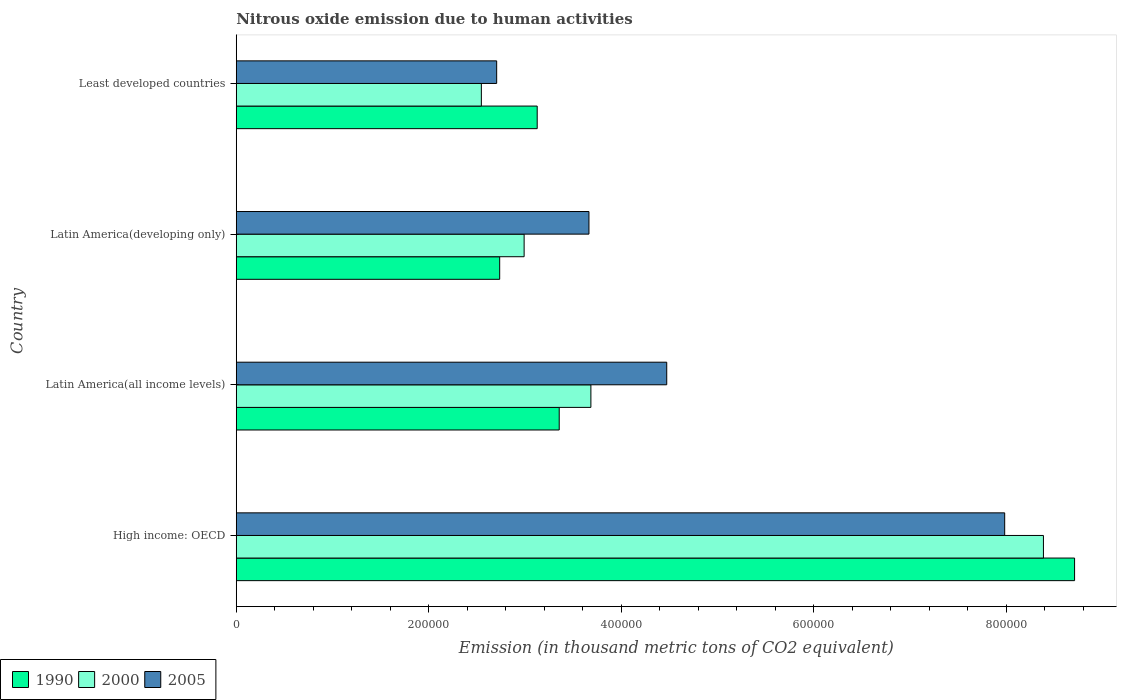How many groups of bars are there?
Give a very brief answer. 4. Are the number of bars per tick equal to the number of legend labels?
Ensure brevity in your answer.  Yes. How many bars are there on the 4th tick from the top?
Your answer should be compact. 3. How many bars are there on the 4th tick from the bottom?
Your answer should be compact. 3. What is the label of the 2nd group of bars from the top?
Provide a succinct answer. Latin America(developing only). In how many cases, is the number of bars for a given country not equal to the number of legend labels?
Your answer should be compact. 0. What is the amount of nitrous oxide emitted in 2000 in Latin America(developing only)?
Give a very brief answer. 2.99e+05. Across all countries, what is the maximum amount of nitrous oxide emitted in 2005?
Offer a terse response. 7.98e+05. Across all countries, what is the minimum amount of nitrous oxide emitted in 2005?
Provide a short and direct response. 2.71e+05. In which country was the amount of nitrous oxide emitted in 2000 maximum?
Offer a very short reply. High income: OECD. In which country was the amount of nitrous oxide emitted in 1990 minimum?
Offer a very short reply. Latin America(developing only). What is the total amount of nitrous oxide emitted in 1990 in the graph?
Offer a very short reply. 1.79e+06. What is the difference between the amount of nitrous oxide emitted in 2005 in Latin America(all income levels) and that in Least developed countries?
Ensure brevity in your answer.  1.77e+05. What is the difference between the amount of nitrous oxide emitted in 2005 in High income: OECD and the amount of nitrous oxide emitted in 2000 in Latin America(developing only)?
Your answer should be very brief. 4.99e+05. What is the average amount of nitrous oxide emitted in 2005 per country?
Keep it short and to the point. 4.71e+05. What is the difference between the amount of nitrous oxide emitted in 2005 and amount of nitrous oxide emitted in 1990 in Latin America(all income levels)?
Your answer should be very brief. 1.12e+05. What is the ratio of the amount of nitrous oxide emitted in 2005 in High income: OECD to that in Latin America(all income levels)?
Ensure brevity in your answer.  1.79. What is the difference between the highest and the second highest amount of nitrous oxide emitted in 2000?
Ensure brevity in your answer.  4.70e+05. What is the difference between the highest and the lowest amount of nitrous oxide emitted in 1990?
Your answer should be compact. 5.97e+05. Is the sum of the amount of nitrous oxide emitted in 2005 in High income: OECD and Latin America(all income levels) greater than the maximum amount of nitrous oxide emitted in 1990 across all countries?
Your answer should be very brief. Yes. What does the 1st bar from the top in Latin America(all income levels) represents?
Give a very brief answer. 2005. What does the 3rd bar from the bottom in Latin America(all income levels) represents?
Provide a short and direct response. 2005. Is it the case that in every country, the sum of the amount of nitrous oxide emitted in 2000 and amount of nitrous oxide emitted in 2005 is greater than the amount of nitrous oxide emitted in 1990?
Your response must be concise. Yes. How many bars are there?
Make the answer very short. 12. What is the difference between two consecutive major ticks on the X-axis?
Your answer should be compact. 2.00e+05. Are the values on the major ticks of X-axis written in scientific E-notation?
Keep it short and to the point. No. Does the graph contain any zero values?
Your answer should be very brief. No. Where does the legend appear in the graph?
Provide a succinct answer. Bottom left. What is the title of the graph?
Keep it short and to the point. Nitrous oxide emission due to human activities. What is the label or title of the X-axis?
Your answer should be very brief. Emission (in thousand metric tons of CO2 equivalent). What is the label or title of the Y-axis?
Ensure brevity in your answer.  Country. What is the Emission (in thousand metric tons of CO2 equivalent) of 1990 in High income: OECD?
Your answer should be very brief. 8.71e+05. What is the Emission (in thousand metric tons of CO2 equivalent) in 2000 in High income: OECD?
Offer a terse response. 8.39e+05. What is the Emission (in thousand metric tons of CO2 equivalent) in 2005 in High income: OECD?
Ensure brevity in your answer.  7.98e+05. What is the Emission (in thousand metric tons of CO2 equivalent) of 1990 in Latin America(all income levels)?
Offer a very short reply. 3.36e+05. What is the Emission (in thousand metric tons of CO2 equivalent) in 2000 in Latin America(all income levels)?
Your answer should be very brief. 3.68e+05. What is the Emission (in thousand metric tons of CO2 equivalent) of 2005 in Latin America(all income levels)?
Make the answer very short. 4.47e+05. What is the Emission (in thousand metric tons of CO2 equivalent) of 1990 in Latin America(developing only)?
Ensure brevity in your answer.  2.74e+05. What is the Emission (in thousand metric tons of CO2 equivalent) of 2000 in Latin America(developing only)?
Give a very brief answer. 2.99e+05. What is the Emission (in thousand metric tons of CO2 equivalent) in 2005 in Latin America(developing only)?
Offer a very short reply. 3.66e+05. What is the Emission (in thousand metric tons of CO2 equivalent) of 1990 in Least developed countries?
Provide a succinct answer. 3.13e+05. What is the Emission (in thousand metric tons of CO2 equivalent) in 2000 in Least developed countries?
Your answer should be compact. 2.55e+05. What is the Emission (in thousand metric tons of CO2 equivalent) of 2005 in Least developed countries?
Provide a succinct answer. 2.71e+05. Across all countries, what is the maximum Emission (in thousand metric tons of CO2 equivalent) of 1990?
Make the answer very short. 8.71e+05. Across all countries, what is the maximum Emission (in thousand metric tons of CO2 equivalent) in 2000?
Offer a terse response. 8.39e+05. Across all countries, what is the maximum Emission (in thousand metric tons of CO2 equivalent) of 2005?
Offer a very short reply. 7.98e+05. Across all countries, what is the minimum Emission (in thousand metric tons of CO2 equivalent) in 1990?
Your answer should be very brief. 2.74e+05. Across all countries, what is the minimum Emission (in thousand metric tons of CO2 equivalent) in 2000?
Ensure brevity in your answer.  2.55e+05. Across all countries, what is the minimum Emission (in thousand metric tons of CO2 equivalent) of 2005?
Give a very brief answer. 2.71e+05. What is the total Emission (in thousand metric tons of CO2 equivalent) in 1990 in the graph?
Provide a succinct answer. 1.79e+06. What is the total Emission (in thousand metric tons of CO2 equivalent) in 2000 in the graph?
Ensure brevity in your answer.  1.76e+06. What is the total Emission (in thousand metric tons of CO2 equivalent) of 2005 in the graph?
Keep it short and to the point. 1.88e+06. What is the difference between the Emission (in thousand metric tons of CO2 equivalent) in 1990 in High income: OECD and that in Latin America(all income levels)?
Make the answer very short. 5.35e+05. What is the difference between the Emission (in thousand metric tons of CO2 equivalent) in 2000 in High income: OECD and that in Latin America(all income levels)?
Give a very brief answer. 4.70e+05. What is the difference between the Emission (in thousand metric tons of CO2 equivalent) in 2005 in High income: OECD and that in Latin America(all income levels)?
Provide a succinct answer. 3.51e+05. What is the difference between the Emission (in thousand metric tons of CO2 equivalent) of 1990 in High income: OECD and that in Latin America(developing only)?
Your answer should be very brief. 5.97e+05. What is the difference between the Emission (in thousand metric tons of CO2 equivalent) of 2000 in High income: OECD and that in Latin America(developing only)?
Provide a short and direct response. 5.40e+05. What is the difference between the Emission (in thousand metric tons of CO2 equivalent) of 2005 in High income: OECD and that in Latin America(developing only)?
Your response must be concise. 4.32e+05. What is the difference between the Emission (in thousand metric tons of CO2 equivalent) in 1990 in High income: OECD and that in Least developed countries?
Your answer should be compact. 5.58e+05. What is the difference between the Emission (in thousand metric tons of CO2 equivalent) of 2000 in High income: OECD and that in Least developed countries?
Make the answer very short. 5.84e+05. What is the difference between the Emission (in thousand metric tons of CO2 equivalent) in 2005 in High income: OECD and that in Least developed countries?
Give a very brief answer. 5.28e+05. What is the difference between the Emission (in thousand metric tons of CO2 equivalent) of 1990 in Latin America(all income levels) and that in Latin America(developing only)?
Your answer should be compact. 6.18e+04. What is the difference between the Emission (in thousand metric tons of CO2 equivalent) of 2000 in Latin America(all income levels) and that in Latin America(developing only)?
Offer a terse response. 6.94e+04. What is the difference between the Emission (in thousand metric tons of CO2 equivalent) of 2005 in Latin America(all income levels) and that in Latin America(developing only)?
Provide a short and direct response. 8.08e+04. What is the difference between the Emission (in thousand metric tons of CO2 equivalent) in 1990 in Latin America(all income levels) and that in Least developed countries?
Your answer should be compact. 2.29e+04. What is the difference between the Emission (in thousand metric tons of CO2 equivalent) of 2000 in Latin America(all income levels) and that in Least developed countries?
Make the answer very short. 1.14e+05. What is the difference between the Emission (in thousand metric tons of CO2 equivalent) in 2005 in Latin America(all income levels) and that in Least developed countries?
Give a very brief answer. 1.77e+05. What is the difference between the Emission (in thousand metric tons of CO2 equivalent) of 1990 in Latin America(developing only) and that in Least developed countries?
Ensure brevity in your answer.  -3.90e+04. What is the difference between the Emission (in thousand metric tons of CO2 equivalent) in 2000 in Latin America(developing only) and that in Least developed countries?
Provide a short and direct response. 4.44e+04. What is the difference between the Emission (in thousand metric tons of CO2 equivalent) in 2005 in Latin America(developing only) and that in Least developed countries?
Your response must be concise. 9.59e+04. What is the difference between the Emission (in thousand metric tons of CO2 equivalent) in 1990 in High income: OECD and the Emission (in thousand metric tons of CO2 equivalent) in 2000 in Latin America(all income levels)?
Your answer should be compact. 5.03e+05. What is the difference between the Emission (in thousand metric tons of CO2 equivalent) of 1990 in High income: OECD and the Emission (in thousand metric tons of CO2 equivalent) of 2005 in Latin America(all income levels)?
Offer a very short reply. 4.24e+05. What is the difference between the Emission (in thousand metric tons of CO2 equivalent) in 2000 in High income: OECD and the Emission (in thousand metric tons of CO2 equivalent) in 2005 in Latin America(all income levels)?
Provide a succinct answer. 3.91e+05. What is the difference between the Emission (in thousand metric tons of CO2 equivalent) of 1990 in High income: OECD and the Emission (in thousand metric tons of CO2 equivalent) of 2000 in Latin America(developing only)?
Offer a terse response. 5.72e+05. What is the difference between the Emission (in thousand metric tons of CO2 equivalent) in 1990 in High income: OECD and the Emission (in thousand metric tons of CO2 equivalent) in 2005 in Latin America(developing only)?
Offer a very short reply. 5.05e+05. What is the difference between the Emission (in thousand metric tons of CO2 equivalent) in 2000 in High income: OECD and the Emission (in thousand metric tons of CO2 equivalent) in 2005 in Latin America(developing only)?
Provide a short and direct response. 4.72e+05. What is the difference between the Emission (in thousand metric tons of CO2 equivalent) in 1990 in High income: OECD and the Emission (in thousand metric tons of CO2 equivalent) in 2000 in Least developed countries?
Your answer should be compact. 6.16e+05. What is the difference between the Emission (in thousand metric tons of CO2 equivalent) of 1990 in High income: OECD and the Emission (in thousand metric tons of CO2 equivalent) of 2005 in Least developed countries?
Keep it short and to the point. 6.00e+05. What is the difference between the Emission (in thousand metric tons of CO2 equivalent) in 2000 in High income: OECD and the Emission (in thousand metric tons of CO2 equivalent) in 2005 in Least developed countries?
Keep it short and to the point. 5.68e+05. What is the difference between the Emission (in thousand metric tons of CO2 equivalent) in 1990 in Latin America(all income levels) and the Emission (in thousand metric tons of CO2 equivalent) in 2000 in Latin America(developing only)?
Your response must be concise. 3.65e+04. What is the difference between the Emission (in thousand metric tons of CO2 equivalent) in 1990 in Latin America(all income levels) and the Emission (in thousand metric tons of CO2 equivalent) in 2005 in Latin America(developing only)?
Your answer should be compact. -3.09e+04. What is the difference between the Emission (in thousand metric tons of CO2 equivalent) in 2000 in Latin America(all income levels) and the Emission (in thousand metric tons of CO2 equivalent) in 2005 in Latin America(developing only)?
Your answer should be very brief. 2012. What is the difference between the Emission (in thousand metric tons of CO2 equivalent) of 1990 in Latin America(all income levels) and the Emission (in thousand metric tons of CO2 equivalent) of 2000 in Least developed countries?
Your response must be concise. 8.09e+04. What is the difference between the Emission (in thousand metric tons of CO2 equivalent) in 1990 in Latin America(all income levels) and the Emission (in thousand metric tons of CO2 equivalent) in 2005 in Least developed countries?
Offer a very short reply. 6.50e+04. What is the difference between the Emission (in thousand metric tons of CO2 equivalent) of 2000 in Latin America(all income levels) and the Emission (in thousand metric tons of CO2 equivalent) of 2005 in Least developed countries?
Provide a short and direct response. 9.79e+04. What is the difference between the Emission (in thousand metric tons of CO2 equivalent) in 1990 in Latin America(developing only) and the Emission (in thousand metric tons of CO2 equivalent) in 2000 in Least developed countries?
Your answer should be very brief. 1.91e+04. What is the difference between the Emission (in thousand metric tons of CO2 equivalent) in 1990 in Latin America(developing only) and the Emission (in thousand metric tons of CO2 equivalent) in 2005 in Least developed countries?
Keep it short and to the point. 3144.7. What is the difference between the Emission (in thousand metric tons of CO2 equivalent) in 2000 in Latin America(developing only) and the Emission (in thousand metric tons of CO2 equivalent) in 2005 in Least developed countries?
Offer a very short reply. 2.85e+04. What is the average Emission (in thousand metric tons of CO2 equivalent) of 1990 per country?
Your response must be concise. 4.48e+05. What is the average Emission (in thousand metric tons of CO2 equivalent) in 2000 per country?
Ensure brevity in your answer.  4.40e+05. What is the average Emission (in thousand metric tons of CO2 equivalent) of 2005 per country?
Provide a succinct answer. 4.71e+05. What is the difference between the Emission (in thousand metric tons of CO2 equivalent) in 1990 and Emission (in thousand metric tons of CO2 equivalent) in 2000 in High income: OECD?
Your answer should be very brief. 3.24e+04. What is the difference between the Emission (in thousand metric tons of CO2 equivalent) in 1990 and Emission (in thousand metric tons of CO2 equivalent) in 2005 in High income: OECD?
Offer a terse response. 7.26e+04. What is the difference between the Emission (in thousand metric tons of CO2 equivalent) of 2000 and Emission (in thousand metric tons of CO2 equivalent) of 2005 in High income: OECD?
Your answer should be compact. 4.02e+04. What is the difference between the Emission (in thousand metric tons of CO2 equivalent) of 1990 and Emission (in thousand metric tons of CO2 equivalent) of 2000 in Latin America(all income levels)?
Offer a terse response. -3.29e+04. What is the difference between the Emission (in thousand metric tons of CO2 equivalent) in 1990 and Emission (in thousand metric tons of CO2 equivalent) in 2005 in Latin America(all income levels)?
Your answer should be compact. -1.12e+05. What is the difference between the Emission (in thousand metric tons of CO2 equivalent) in 2000 and Emission (in thousand metric tons of CO2 equivalent) in 2005 in Latin America(all income levels)?
Offer a terse response. -7.88e+04. What is the difference between the Emission (in thousand metric tons of CO2 equivalent) of 1990 and Emission (in thousand metric tons of CO2 equivalent) of 2000 in Latin America(developing only)?
Your response must be concise. -2.54e+04. What is the difference between the Emission (in thousand metric tons of CO2 equivalent) in 1990 and Emission (in thousand metric tons of CO2 equivalent) in 2005 in Latin America(developing only)?
Provide a short and direct response. -9.27e+04. What is the difference between the Emission (in thousand metric tons of CO2 equivalent) in 2000 and Emission (in thousand metric tons of CO2 equivalent) in 2005 in Latin America(developing only)?
Your answer should be very brief. -6.74e+04. What is the difference between the Emission (in thousand metric tons of CO2 equivalent) in 1990 and Emission (in thousand metric tons of CO2 equivalent) in 2000 in Least developed countries?
Give a very brief answer. 5.80e+04. What is the difference between the Emission (in thousand metric tons of CO2 equivalent) of 1990 and Emission (in thousand metric tons of CO2 equivalent) of 2005 in Least developed countries?
Your answer should be very brief. 4.21e+04. What is the difference between the Emission (in thousand metric tons of CO2 equivalent) of 2000 and Emission (in thousand metric tons of CO2 equivalent) of 2005 in Least developed countries?
Your answer should be compact. -1.59e+04. What is the ratio of the Emission (in thousand metric tons of CO2 equivalent) of 1990 in High income: OECD to that in Latin America(all income levels)?
Provide a short and direct response. 2.6. What is the ratio of the Emission (in thousand metric tons of CO2 equivalent) in 2000 in High income: OECD to that in Latin America(all income levels)?
Your answer should be compact. 2.28. What is the ratio of the Emission (in thousand metric tons of CO2 equivalent) of 2005 in High income: OECD to that in Latin America(all income levels)?
Provide a succinct answer. 1.78. What is the ratio of the Emission (in thousand metric tons of CO2 equivalent) in 1990 in High income: OECD to that in Latin America(developing only)?
Offer a very short reply. 3.18. What is the ratio of the Emission (in thousand metric tons of CO2 equivalent) of 2000 in High income: OECD to that in Latin America(developing only)?
Make the answer very short. 2.8. What is the ratio of the Emission (in thousand metric tons of CO2 equivalent) of 2005 in High income: OECD to that in Latin America(developing only)?
Make the answer very short. 2.18. What is the ratio of the Emission (in thousand metric tons of CO2 equivalent) in 1990 in High income: OECD to that in Least developed countries?
Your response must be concise. 2.79. What is the ratio of the Emission (in thousand metric tons of CO2 equivalent) of 2000 in High income: OECD to that in Least developed countries?
Your answer should be very brief. 3.29. What is the ratio of the Emission (in thousand metric tons of CO2 equivalent) in 2005 in High income: OECD to that in Least developed countries?
Make the answer very short. 2.95. What is the ratio of the Emission (in thousand metric tons of CO2 equivalent) of 1990 in Latin America(all income levels) to that in Latin America(developing only)?
Provide a succinct answer. 1.23. What is the ratio of the Emission (in thousand metric tons of CO2 equivalent) in 2000 in Latin America(all income levels) to that in Latin America(developing only)?
Provide a short and direct response. 1.23. What is the ratio of the Emission (in thousand metric tons of CO2 equivalent) in 2005 in Latin America(all income levels) to that in Latin America(developing only)?
Provide a succinct answer. 1.22. What is the ratio of the Emission (in thousand metric tons of CO2 equivalent) of 1990 in Latin America(all income levels) to that in Least developed countries?
Provide a short and direct response. 1.07. What is the ratio of the Emission (in thousand metric tons of CO2 equivalent) of 2000 in Latin America(all income levels) to that in Least developed countries?
Ensure brevity in your answer.  1.45. What is the ratio of the Emission (in thousand metric tons of CO2 equivalent) in 2005 in Latin America(all income levels) to that in Least developed countries?
Your answer should be compact. 1.65. What is the ratio of the Emission (in thousand metric tons of CO2 equivalent) of 1990 in Latin America(developing only) to that in Least developed countries?
Provide a succinct answer. 0.88. What is the ratio of the Emission (in thousand metric tons of CO2 equivalent) of 2000 in Latin America(developing only) to that in Least developed countries?
Keep it short and to the point. 1.17. What is the ratio of the Emission (in thousand metric tons of CO2 equivalent) in 2005 in Latin America(developing only) to that in Least developed countries?
Keep it short and to the point. 1.35. What is the difference between the highest and the second highest Emission (in thousand metric tons of CO2 equivalent) of 1990?
Your answer should be very brief. 5.35e+05. What is the difference between the highest and the second highest Emission (in thousand metric tons of CO2 equivalent) in 2000?
Offer a very short reply. 4.70e+05. What is the difference between the highest and the second highest Emission (in thousand metric tons of CO2 equivalent) of 2005?
Your answer should be very brief. 3.51e+05. What is the difference between the highest and the lowest Emission (in thousand metric tons of CO2 equivalent) of 1990?
Ensure brevity in your answer.  5.97e+05. What is the difference between the highest and the lowest Emission (in thousand metric tons of CO2 equivalent) of 2000?
Your response must be concise. 5.84e+05. What is the difference between the highest and the lowest Emission (in thousand metric tons of CO2 equivalent) of 2005?
Offer a terse response. 5.28e+05. 